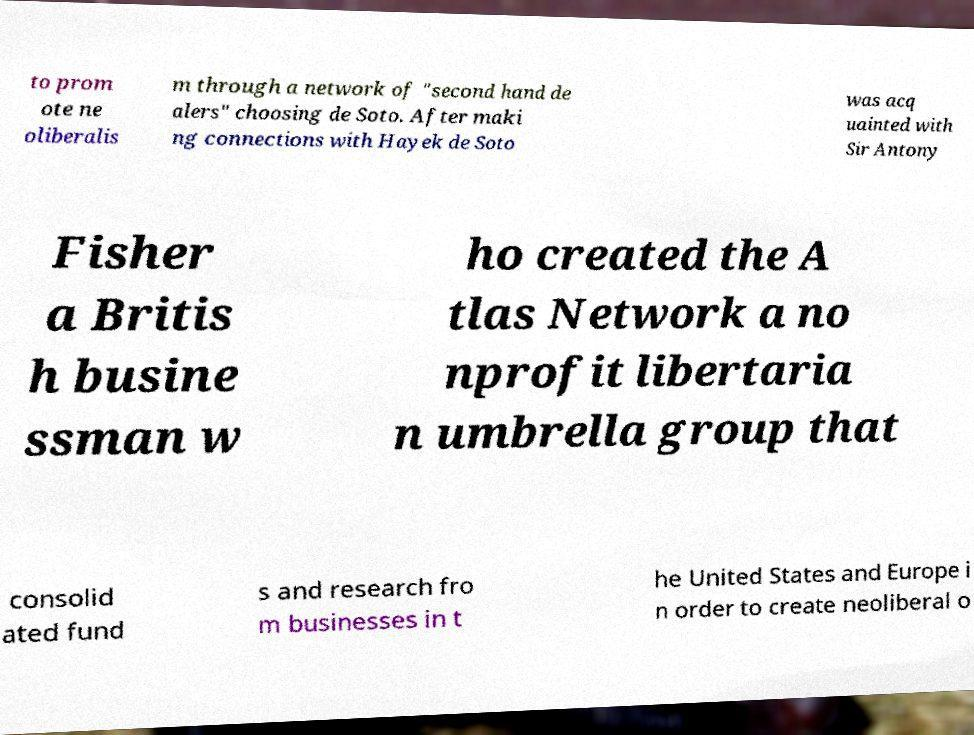What messages or text are displayed in this image? I need them in a readable, typed format. to prom ote ne oliberalis m through a network of "second hand de alers" choosing de Soto. After maki ng connections with Hayek de Soto was acq uainted with Sir Antony Fisher a Britis h busine ssman w ho created the A tlas Network a no nprofit libertaria n umbrella group that consolid ated fund s and research fro m businesses in t he United States and Europe i n order to create neoliberal o 